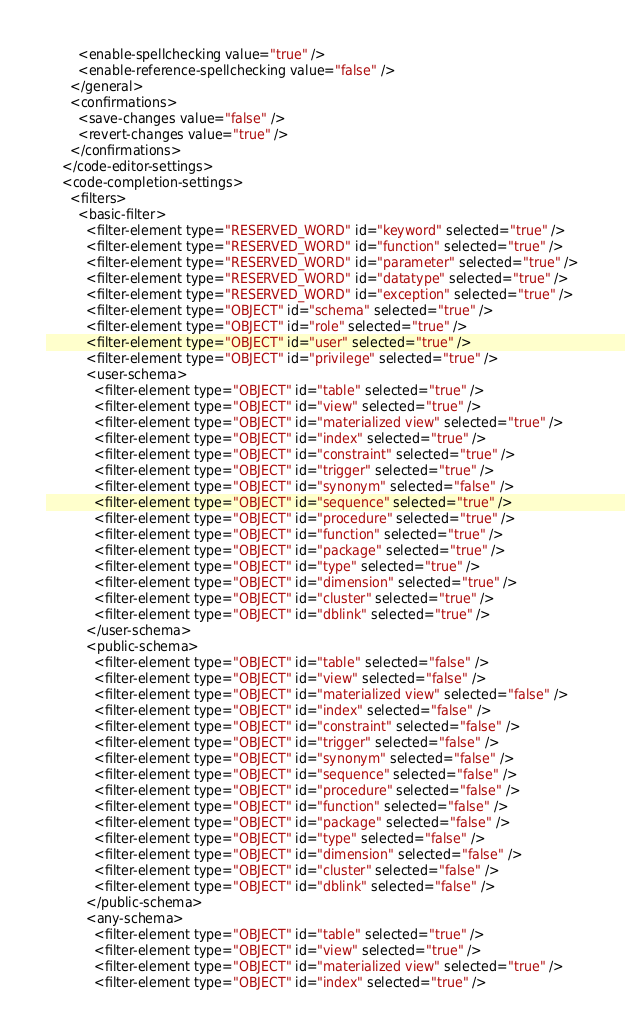<code> <loc_0><loc_0><loc_500><loc_500><_XML_>        <enable-spellchecking value="true" />
        <enable-reference-spellchecking value="false" />
      </general>
      <confirmations>
        <save-changes value="false" />
        <revert-changes value="true" />
      </confirmations>
    </code-editor-settings>
    <code-completion-settings>
      <filters>
        <basic-filter>
          <filter-element type="RESERVED_WORD" id="keyword" selected="true" />
          <filter-element type="RESERVED_WORD" id="function" selected="true" />
          <filter-element type="RESERVED_WORD" id="parameter" selected="true" />
          <filter-element type="RESERVED_WORD" id="datatype" selected="true" />
          <filter-element type="RESERVED_WORD" id="exception" selected="true" />
          <filter-element type="OBJECT" id="schema" selected="true" />
          <filter-element type="OBJECT" id="role" selected="true" />
          <filter-element type="OBJECT" id="user" selected="true" />
          <filter-element type="OBJECT" id="privilege" selected="true" />
          <user-schema>
            <filter-element type="OBJECT" id="table" selected="true" />
            <filter-element type="OBJECT" id="view" selected="true" />
            <filter-element type="OBJECT" id="materialized view" selected="true" />
            <filter-element type="OBJECT" id="index" selected="true" />
            <filter-element type="OBJECT" id="constraint" selected="true" />
            <filter-element type="OBJECT" id="trigger" selected="true" />
            <filter-element type="OBJECT" id="synonym" selected="false" />
            <filter-element type="OBJECT" id="sequence" selected="true" />
            <filter-element type="OBJECT" id="procedure" selected="true" />
            <filter-element type="OBJECT" id="function" selected="true" />
            <filter-element type="OBJECT" id="package" selected="true" />
            <filter-element type="OBJECT" id="type" selected="true" />
            <filter-element type="OBJECT" id="dimension" selected="true" />
            <filter-element type="OBJECT" id="cluster" selected="true" />
            <filter-element type="OBJECT" id="dblink" selected="true" />
          </user-schema>
          <public-schema>
            <filter-element type="OBJECT" id="table" selected="false" />
            <filter-element type="OBJECT" id="view" selected="false" />
            <filter-element type="OBJECT" id="materialized view" selected="false" />
            <filter-element type="OBJECT" id="index" selected="false" />
            <filter-element type="OBJECT" id="constraint" selected="false" />
            <filter-element type="OBJECT" id="trigger" selected="false" />
            <filter-element type="OBJECT" id="synonym" selected="false" />
            <filter-element type="OBJECT" id="sequence" selected="false" />
            <filter-element type="OBJECT" id="procedure" selected="false" />
            <filter-element type="OBJECT" id="function" selected="false" />
            <filter-element type="OBJECT" id="package" selected="false" />
            <filter-element type="OBJECT" id="type" selected="false" />
            <filter-element type="OBJECT" id="dimension" selected="false" />
            <filter-element type="OBJECT" id="cluster" selected="false" />
            <filter-element type="OBJECT" id="dblink" selected="false" />
          </public-schema>
          <any-schema>
            <filter-element type="OBJECT" id="table" selected="true" />
            <filter-element type="OBJECT" id="view" selected="true" />
            <filter-element type="OBJECT" id="materialized view" selected="true" />
            <filter-element type="OBJECT" id="index" selected="true" /></code> 